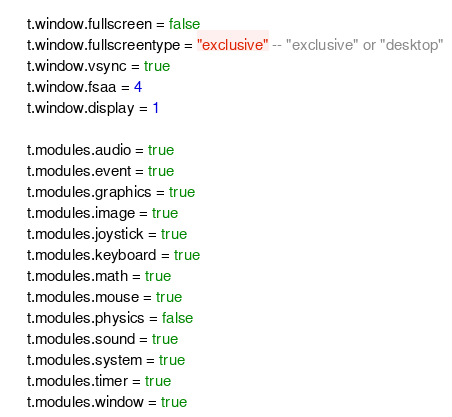Convert code to text. <code><loc_0><loc_0><loc_500><loc_500><_MoonScript_>    t.window.fullscreen = false
    t.window.fullscreentype = "exclusive" -- "exclusive" or "desktop"
    t.window.vsync = true
    t.window.fsaa = 4
    t.window.display = 1

    t.modules.audio = true
    t.modules.event = true
    t.modules.graphics = true
    t.modules.image = true
    t.modules.joystick = true
    t.modules.keyboard = true
    t.modules.math = true
    t.modules.mouse = true
    t.modules.physics = false
    t.modules.sound = true
    t.modules.system = true
    t.modules.timer = true
    t.modules.window = true
</code> 